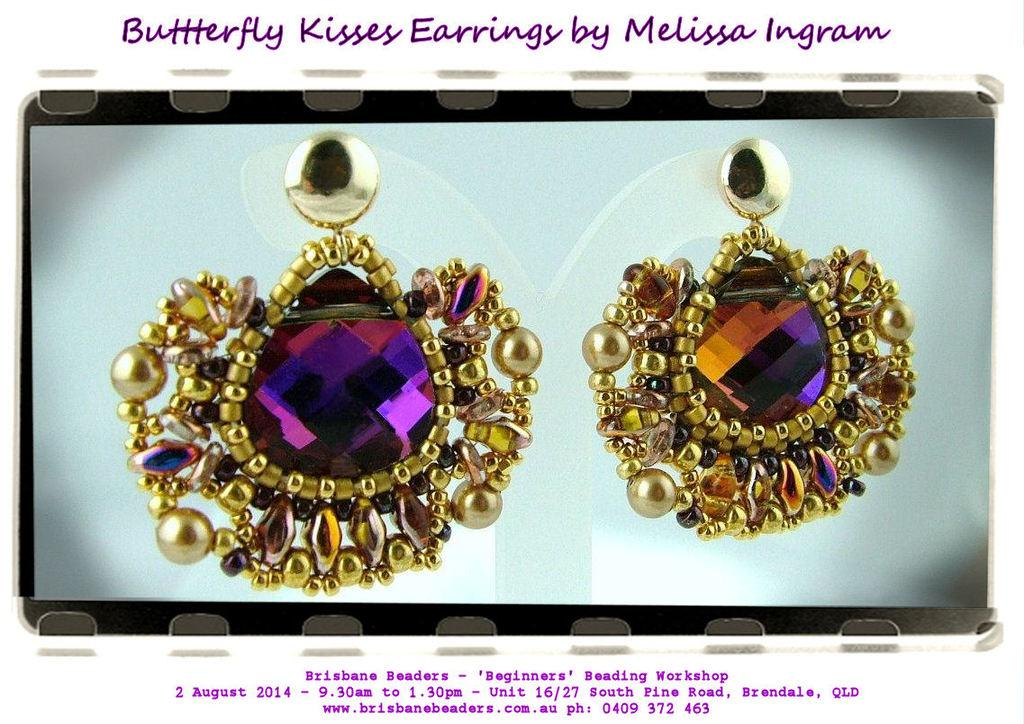Provide a one-sentence caption for the provided image. Large purple and gold earrings called the Butterfly Kisses sit on a gray background. 